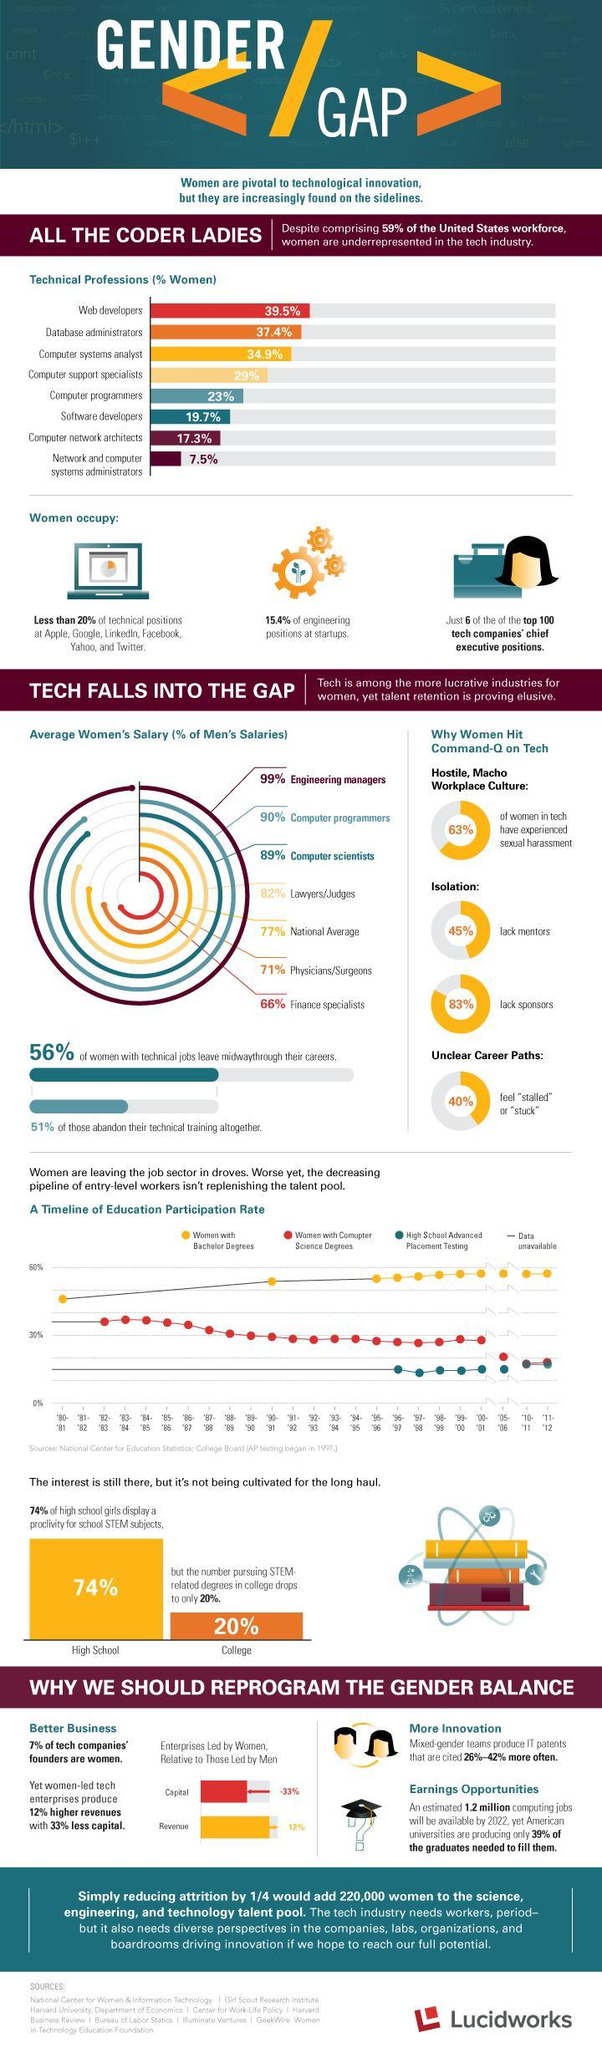What is the percentage of women pursuing computer science degrees 2005-2006?
Answer the question with a short phrase. 20% 